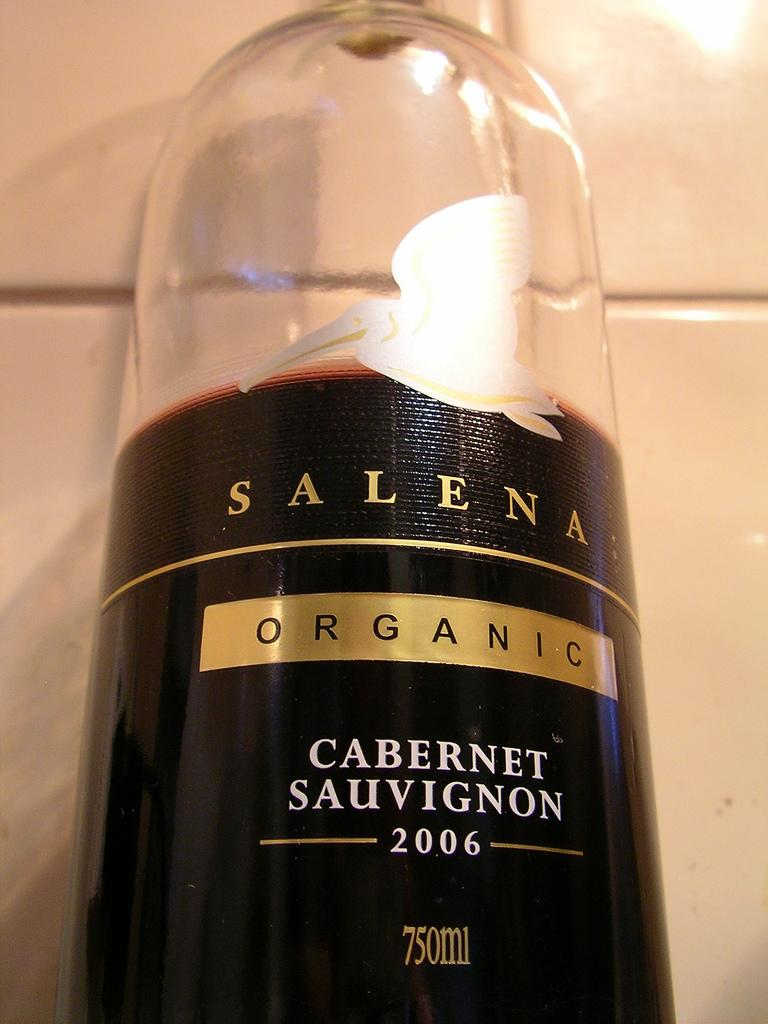What type of object is in the image? There is a cosmetic bottle in the image. What type of rice is being grown in the territory shown in the image? There is no territory or rice present in the image; it only features a cosmetic bottle. 